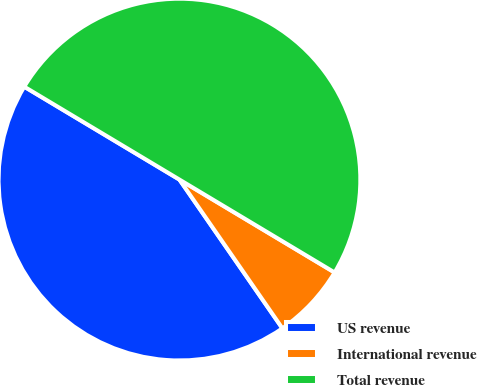Convert chart. <chart><loc_0><loc_0><loc_500><loc_500><pie_chart><fcel>US revenue<fcel>International revenue<fcel>Total revenue<nl><fcel>43.22%<fcel>6.78%<fcel>50.0%<nl></chart> 